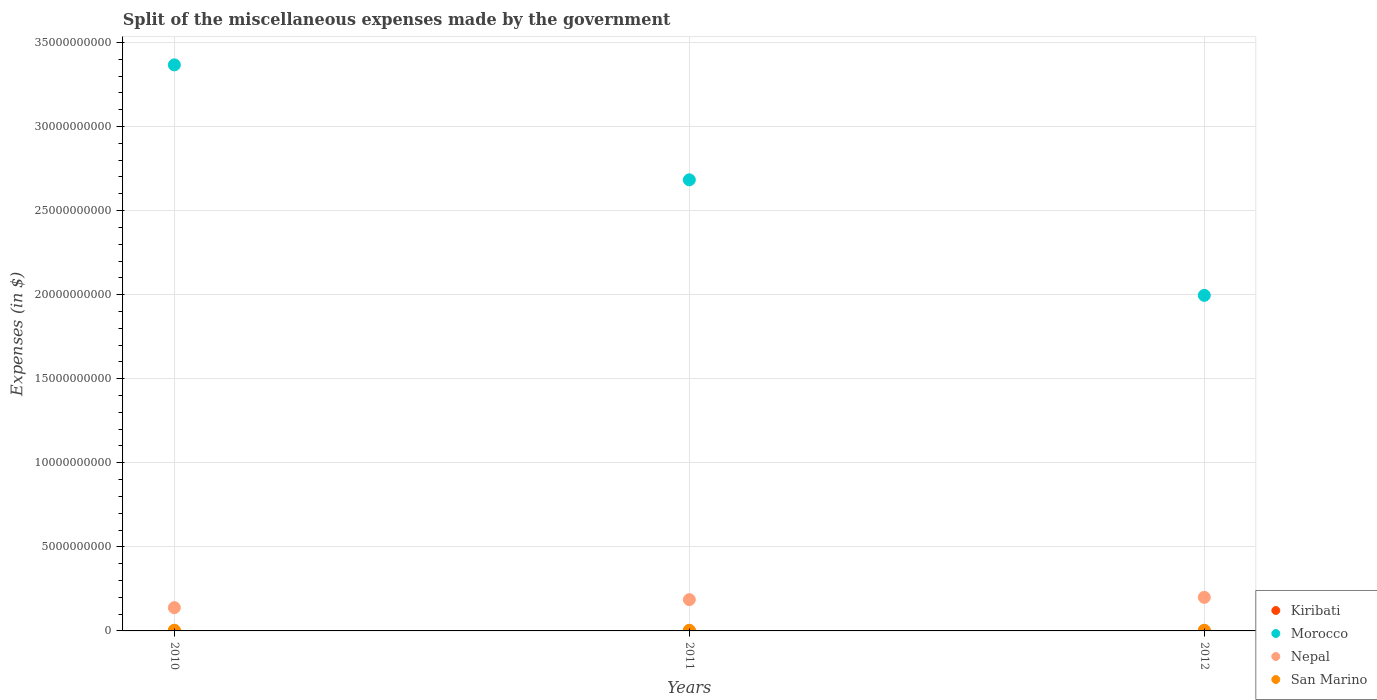What is the miscellaneous expenses made by the government in Kiribati in 2011?
Offer a very short reply. 4.65e+06. Across all years, what is the maximum miscellaneous expenses made by the government in Nepal?
Provide a short and direct response. 2.00e+09. Across all years, what is the minimum miscellaneous expenses made by the government in San Marino?
Offer a terse response. 3.76e+07. In which year was the miscellaneous expenses made by the government in Morocco minimum?
Your answer should be very brief. 2012. What is the total miscellaneous expenses made by the government in San Marino in the graph?
Your answer should be very brief. 1.17e+08. What is the difference between the miscellaneous expenses made by the government in Kiribati in 2010 and that in 2012?
Give a very brief answer. 6.88e+05. What is the difference between the miscellaneous expenses made by the government in Kiribati in 2011 and the miscellaneous expenses made by the government in Morocco in 2012?
Provide a succinct answer. -2.00e+1. What is the average miscellaneous expenses made by the government in Nepal per year?
Your answer should be very brief. 1.75e+09. In the year 2011, what is the difference between the miscellaneous expenses made by the government in San Marino and miscellaneous expenses made by the government in Nepal?
Keep it short and to the point. -1.82e+09. In how many years, is the miscellaneous expenses made by the government in San Marino greater than 8000000000 $?
Offer a terse response. 0. What is the ratio of the miscellaneous expenses made by the government in Morocco in 2010 to that in 2011?
Provide a short and direct response. 1.25. What is the difference between the highest and the second highest miscellaneous expenses made by the government in Kiribati?
Offer a terse response. 3.65e+05. What is the difference between the highest and the lowest miscellaneous expenses made by the government in San Marino?
Give a very brief answer. 2.44e+06. In how many years, is the miscellaneous expenses made by the government in Kiribati greater than the average miscellaneous expenses made by the government in Kiribati taken over all years?
Your answer should be very brief. 2. Is the sum of the miscellaneous expenses made by the government in Nepal in 2010 and 2011 greater than the maximum miscellaneous expenses made by the government in Morocco across all years?
Make the answer very short. No. Is the miscellaneous expenses made by the government in San Marino strictly greater than the miscellaneous expenses made by the government in Morocco over the years?
Ensure brevity in your answer.  No. How many years are there in the graph?
Your response must be concise. 3. What is the difference between two consecutive major ticks on the Y-axis?
Ensure brevity in your answer.  5.00e+09. Are the values on the major ticks of Y-axis written in scientific E-notation?
Give a very brief answer. No. Does the graph contain any zero values?
Provide a succinct answer. No. Does the graph contain grids?
Give a very brief answer. Yes. Where does the legend appear in the graph?
Make the answer very short. Bottom right. How many legend labels are there?
Your answer should be very brief. 4. What is the title of the graph?
Your answer should be compact. Split of the miscellaneous expenses made by the government. Does "Nicaragua" appear as one of the legend labels in the graph?
Keep it short and to the point. No. What is the label or title of the Y-axis?
Your answer should be very brief. Expenses (in $). What is the Expenses (in $) in Kiribati in 2010?
Keep it short and to the point. 4.28e+06. What is the Expenses (in $) in Morocco in 2010?
Provide a succinct answer. 3.37e+1. What is the Expenses (in $) in Nepal in 2010?
Keep it short and to the point. 1.38e+09. What is the Expenses (in $) in San Marino in 2010?
Provide a succinct answer. 4.00e+07. What is the Expenses (in $) in Kiribati in 2011?
Give a very brief answer. 4.65e+06. What is the Expenses (in $) of Morocco in 2011?
Provide a short and direct response. 2.68e+1. What is the Expenses (in $) in Nepal in 2011?
Make the answer very short. 1.86e+09. What is the Expenses (in $) in San Marino in 2011?
Your response must be concise. 3.76e+07. What is the Expenses (in $) in Kiribati in 2012?
Give a very brief answer. 3.59e+06. What is the Expenses (in $) of Morocco in 2012?
Give a very brief answer. 2.00e+1. What is the Expenses (in $) of Nepal in 2012?
Make the answer very short. 2.00e+09. What is the Expenses (in $) in San Marino in 2012?
Your answer should be compact. 3.99e+07. Across all years, what is the maximum Expenses (in $) of Kiribati?
Provide a succinct answer. 4.65e+06. Across all years, what is the maximum Expenses (in $) in Morocco?
Your answer should be very brief. 3.37e+1. Across all years, what is the maximum Expenses (in $) in Nepal?
Give a very brief answer. 2.00e+09. Across all years, what is the maximum Expenses (in $) of San Marino?
Provide a succinct answer. 4.00e+07. Across all years, what is the minimum Expenses (in $) in Kiribati?
Make the answer very short. 3.59e+06. Across all years, what is the minimum Expenses (in $) in Morocco?
Your answer should be very brief. 2.00e+1. Across all years, what is the minimum Expenses (in $) of Nepal?
Make the answer very short. 1.38e+09. Across all years, what is the minimum Expenses (in $) of San Marino?
Your answer should be compact. 3.76e+07. What is the total Expenses (in $) of Kiribati in the graph?
Offer a terse response. 1.25e+07. What is the total Expenses (in $) in Morocco in the graph?
Ensure brevity in your answer.  8.05e+1. What is the total Expenses (in $) of Nepal in the graph?
Offer a terse response. 5.24e+09. What is the total Expenses (in $) in San Marino in the graph?
Provide a succinct answer. 1.17e+08. What is the difference between the Expenses (in $) in Kiribati in 2010 and that in 2011?
Give a very brief answer. -3.65e+05. What is the difference between the Expenses (in $) in Morocco in 2010 and that in 2011?
Keep it short and to the point. 6.84e+09. What is the difference between the Expenses (in $) in Nepal in 2010 and that in 2011?
Offer a terse response. -4.77e+08. What is the difference between the Expenses (in $) in San Marino in 2010 and that in 2011?
Your response must be concise. 2.44e+06. What is the difference between the Expenses (in $) of Kiribati in 2010 and that in 2012?
Your response must be concise. 6.88e+05. What is the difference between the Expenses (in $) of Morocco in 2010 and that in 2012?
Offer a very short reply. 1.37e+1. What is the difference between the Expenses (in $) of Nepal in 2010 and that in 2012?
Give a very brief answer. -6.13e+08. What is the difference between the Expenses (in $) of San Marino in 2010 and that in 2012?
Your answer should be compact. 1.60e+05. What is the difference between the Expenses (in $) of Kiribati in 2011 and that in 2012?
Provide a succinct answer. 1.05e+06. What is the difference between the Expenses (in $) of Morocco in 2011 and that in 2012?
Give a very brief answer. 6.87e+09. What is the difference between the Expenses (in $) in Nepal in 2011 and that in 2012?
Your response must be concise. -1.36e+08. What is the difference between the Expenses (in $) in San Marino in 2011 and that in 2012?
Provide a short and direct response. -2.28e+06. What is the difference between the Expenses (in $) in Kiribati in 2010 and the Expenses (in $) in Morocco in 2011?
Provide a succinct answer. -2.68e+1. What is the difference between the Expenses (in $) in Kiribati in 2010 and the Expenses (in $) in Nepal in 2011?
Make the answer very short. -1.86e+09. What is the difference between the Expenses (in $) in Kiribati in 2010 and the Expenses (in $) in San Marino in 2011?
Provide a succinct answer. -3.33e+07. What is the difference between the Expenses (in $) of Morocco in 2010 and the Expenses (in $) of Nepal in 2011?
Provide a succinct answer. 3.18e+1. What is the difference between the Expenses (in $) in Morocco in 2010 and the Expenses (in $) in San Marino in 2011?
Make the answer very short. 3.36e+1. What is the difference between the Expenses (in $) of Nepal in 2010 and the Expenses (in $) of San Marino in 2011?
Your response must be concise. 1.35e+09. What is the difference between the Expenses (in $) in Kiribati in 2010 and the Expenses (in $) in Morocco in 2012?
Your answer should be compact. -2.00e+1. What is the difference between the Expenses (in $) in Kiribati in 2010 and the Expenses (in $) in Nepal in 2012?
Your response must be concise. -1.99e+09. What is the difference between the Expenses (in $) of Kiribati in 2010 and the Expenses (in $) of San Marino in 2012?
Give a very brief answer. -3.56e+07. What is the difference between the Expenses (in $) in Morocco in 2010 and the Expenses (in $) in Nepal in 2012?
Keep it short and to the point. 3.17e+1. What is the difference between the Expenses (in $) in Morocco in 2010 and the Expenses (in $) in San Marino in 2012?
Ensure brevity in your answer.  3.36e+1. What is the difference between the Expenses (in $) of Nepal in 2010 and the Expenses (in $) of San Marino in 2012?
Your answer should be very brief. 1.34e+09. What is the difference between the Expenses (in $) of Kiribati in 2011 and the Expenses (in $) of Morocco in 2012?
Provide a short and direct response. -2.00e+1. What is the difference between the Expenses (in $) of Kiribati in 2011 and the Expenses (in $) of Nepal in 2012?
Your answer should be very brief. -1.99e+09. What is the difference between the Expenses (in $) of Kiribati in 2011 and the Expenses (in $) of San Marino in 2012?
Your answer should be compact. -3.52e+07. What is the difference between the Expenses (in $) in Morocco in 2011 and the Expenses (in $) in Nepal in 2012?
Provide a succinct answer. 2.48e+1. What is the difference between the Expenses (in $) of Morocco in 2011 and the Expenses (in $) of San Marino in 2012?
Your answer should be very brief. 2.68e+1. What is the difference between the Expenses (in $) of Nepal in 2011 and the Expenses (in $) of San Marino in 2012?
Your answer should be compact. 1.82e+09. What is the average Expenses (in $) in Kiribati per year?
Provide a succinct answer. 4.17e+06. What is the average Expenses (in $) of Morocco per year?
Provide a short and direct response. 2.68e+1. What is the average Expenses (in $) in Nepal per year?
Offer a very short reply. 1.75e+09. What is the average Expenses (in $) of San Marino per year?
Keep it short and to the point. 3.91e+07. In the year 2010, what is the difference between the Expenses (in $) in Kiribati and Expenses (in $) in Morocco?
Your answer should be compact. -3.37e+1. In the year 2010, what is the difference between the Expenses (in $) in Kiribati and Expenses (in $) in Nepal?
Your answer should be very brief. -1.38e+09. In the year 2010, what is the difference between the Expenses (in $) in Kiribati and Expenses (in $) in San Marino?
Your answer should be compact. -3.57e+07. In the year 2010, what is the difference between the Expenses (in $) of Morocco and Expenses (in $) of Nepal?
Give a very brief answer. 3.23e+1. In the year 2010, what is the difference between the Expenses (in $) of Morocco and Expenses (in $) of San Marino?
Make the answer very short. 3.36e+1. In the year 2010, what is the difference between the Expenses (in $) of Nepal and Expenses (in $) of San Marino?
Offer a very short reply. 1.34e+09. In the year 2011, what is the difference between the Expenses (in $) of Kiribati and Expenses (in $) of Morocco?
Give a very brief answer. -2.68e+1. In the year 2011, what is the difference between the Expenses (in $) of Kiribati and Expenses (in $) of Nepal?
Offer a very short reply. -1.86e+09. In the year 2011, what is the difference between the Expenses (in $) in Kiribati and Expenses (in $) in San Marino?
Ensure brevity in your answer.  -3.29e+07. In the year 2011, what is the difference between the Expenses (in $) in Morocco and Expenses (in $) in Nepal?
Provide a short and direct response. 2.50e+1. In the year 2011, what is the difference between the Expenses (in $) in Morocco and Expenses (in $) in San Marino?
Your response must be concise. 2.68e+1. In the year 2011, what is the difference between the Expenses (in $) of Nepal and Expenses (in $) of San Marino?
Your response must be concise. 1.82e+09. In the year 2012, what is the difference between the Expenses (in $) in Kiribati and Expenses (in $) in Morocco?
Keep it short and to the point. -2.00e+1. In the year 2012, what is the difference between the Expenses (in $) of Kiribati and Expenses (in $) of Nepal?
Ensure brevity in your answer.  -1.99e+09. In the year 2012, what is the difference between the Expenses (in $) in Kiribati and Expenses (in $) in San Marino?
Your answer should be very brief. -3.63e+07. In the year 2012, what is the difference between the Expenses (in $) of Morocco and Expenses (in $) of Nepal?
Make the answer very short. 1.80e+1. In the year 2012, what is the difference between the Expenses (in $) in Morocco and Expenses (in $) in San Marino?
Your answer should be compact. 1.99e+1. In the year 2012, what is the difference between the Expenses (in $) in Nepal and Expenses (in $) in San Marino?
Your answer should be very brief. 1.96e+09. What is the ratio of the Expenses (in $) in Kiribati in 2010 to that in 2011?
Give a very brief answer. 0.92. What is the ratio of the Expenses (in $) of Morocco in 2010 to that in 2011?
Offer a very short reply. 1.25. What is the ratio of the Expenses (in $) of Nepal in 2010 to that in 2011?
Keep it short and to the point. 0.74. What is the ratio of the Expenses (in $) of San Marino in 2010 to that in 2011?
Offer a very short reply. 1.06. What is the ratio of the Expenses (in $) in Kiribati in 2010 to that in 2012?
Provide a succinct answer. 1.19. What is the ratio of the Expenses (in $) in Morocco in 2010 to that in 2012?
Ensure brevity in your answer.  1.69. What is the ratio of the Expenses (in $) in Nepal in 2010 to that in 2012?
Your answer should be compact. 0.69. What is the ratio of the Expenses (in $) of San Marino in 2010 to that in 2012?
Your response must be concise. 1. What is the ratio of the Expenses (in $) in Kiribati in 2011 to that in 2012?
Provide a short and direct response. 1.29. What is the ratio of the Expenses (in $) of Morocco in 2011 to that in 2012?
Provide a succinct answer. 1.34. What is the ratio of the Expenses (in $) of Nepal in 2011 to that in 2012?
Offer a very short reply. 0.93. What is the ratio of the Expenses (in $) of San Marino in 2011 to that in 2012?
Your response must be concise. 0.94. What is the difference between the highest and the second highest Expenses (in $) in Kiribati?
Offer a terse response. 3.65e+05. What is the difference between the highest and the second highest Expenses (in $) of Morocco?
Your answer should be compact. 6.84e+09. What is the difference between the highest and the second highest Expenses (in $) in Nepal?
Your response must be concise. 1.36e+08. What is the difference between the highest and the second highest Expenses (in $) of San Marino?
Provide a succinct answer. 1.60e+05. What is the difference between the highest and the lowest Expenses (in $) of Kiribati?
Your answer should be compact. 1.05e+06. What is the difference between the highest and the lowest Expenses (in $) of Morocco?
Provide a short and direct response. 1.37e+1. What is the difference between the highest and the lowest Expenses (in $) of Nepal?
Give a very brief answer. 6.13e+08. What is the difference between the highest and the lowest Expenses (in $) of San Marino?
Keep it short and to the point. 2.44e+06. 